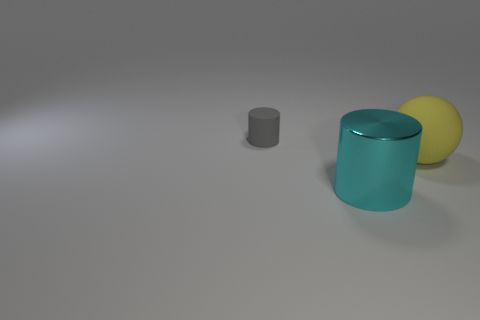Add 3 yellow rubber objects. How many objects exist? 6 Subtract 2 cylinders. How many cylinders are left? 0 Subtract all cyan cylinders. How many cylinders are left? 1 Add 2 matte spheres. How many matte spheres exist? 3 Subtract 0 red balls. How many objects are left? 3 Subtract all cylinders. How many objects are left? 1 Subtract all cyan cylinders. Subtract all red balls. How many cylinders are left? 1 Subtract all matte balls. Subtract all large green metal balls. How many objects are left? 2 Add 2 cyan objects. How many cyan objects are left? 3 